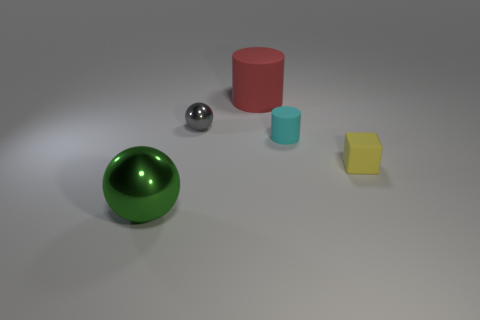What number of other things are the same shape as the yellow matte object?
Your response must be concise. 0. What color is the big shiny sphere to the left of the small thing in front of the cylinder on the right side of the red matte thing?
Your answer should be very brief. Green. How many tiny yellow cubes are there?
Provide a short and direct response. 1. How many big things are either cylinders or red cylinders?
Make the answer very short. 1. There is a cyan object that is the same size as the gray sphere; what shape is it?
Your response must be concise. Cylinder. There is a big object behind the metal object behind the green metal thing; what is it made of?
Your answer should be compact. Rubber. Do the green metallic thing and the gray thing have the same size?
Offer a very short reply. No. How many objects are either tiny yellow matte things in front of the tiny cyan rubber object or gray metal balls?
Give a very brief answer. 2. What is the shape of the big object to the right of the metallic ball behind the tiny yellow object?
Your response must be concise. Cylinder. There is a cube; is it the same size as the metal thing that is behind the small cyan cylinder?
Make the answer very short. Yes. 